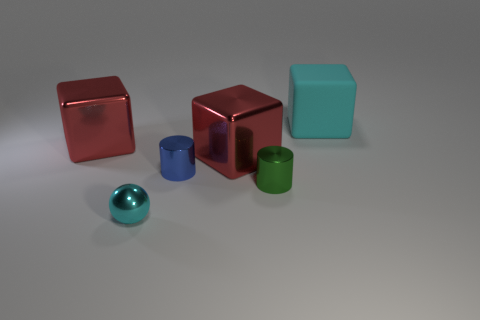Subtract all purple cylinders. How many red cubes are left? 2 Subtract 1 blocks. How many blocks are left? 2 Add 1 large shiny blocks. How many objects exist? 7 Subtract all big red metal blocks. How many blocks are left? 1 Subtract all cylinders. How many objects are left? 4 Subtract all small green cylinders. Subtract all tiny shiny spheres. How many objects are left? 4 Add 5 large cubes. How many large cubes are left? 8 Add 5 rubber blocks. How many rubber blocks exist? 6 Subtract 0 yellow balls. How many objects are left? 6 